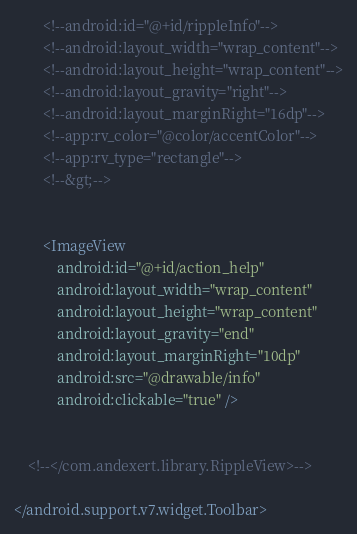<code> <loc_0><loc_0><loc_500><loc_500><_XML_>        <!--android:id="@+id/rippleInfo"-->
        <!--android:layout_width="wrap_content"-->
        <!--android:layout_height="wrap_content"-->
        <!--android:layout_gravity="right"-->
        <!--android:layout_marginRight="16dp"-->
        <!--app:rv_color="@color/accentColor"-->
        <!--app:rv_type="rectangle"-->
        <!--&gt;-->


        <ImageView
            android:id="@+id/action_help"
            android:layout_width="wrap_content"
            android:layout_height="wrap_content"
            android:layout_gravity="end"
            android:layout_marginRight="10dp"
            android:src="@drawable/info"
            android:clickable="true" />


    <!--</com.andexert.library.RippleView>-->

</android.support.v7.widget.Toolbar></code> 